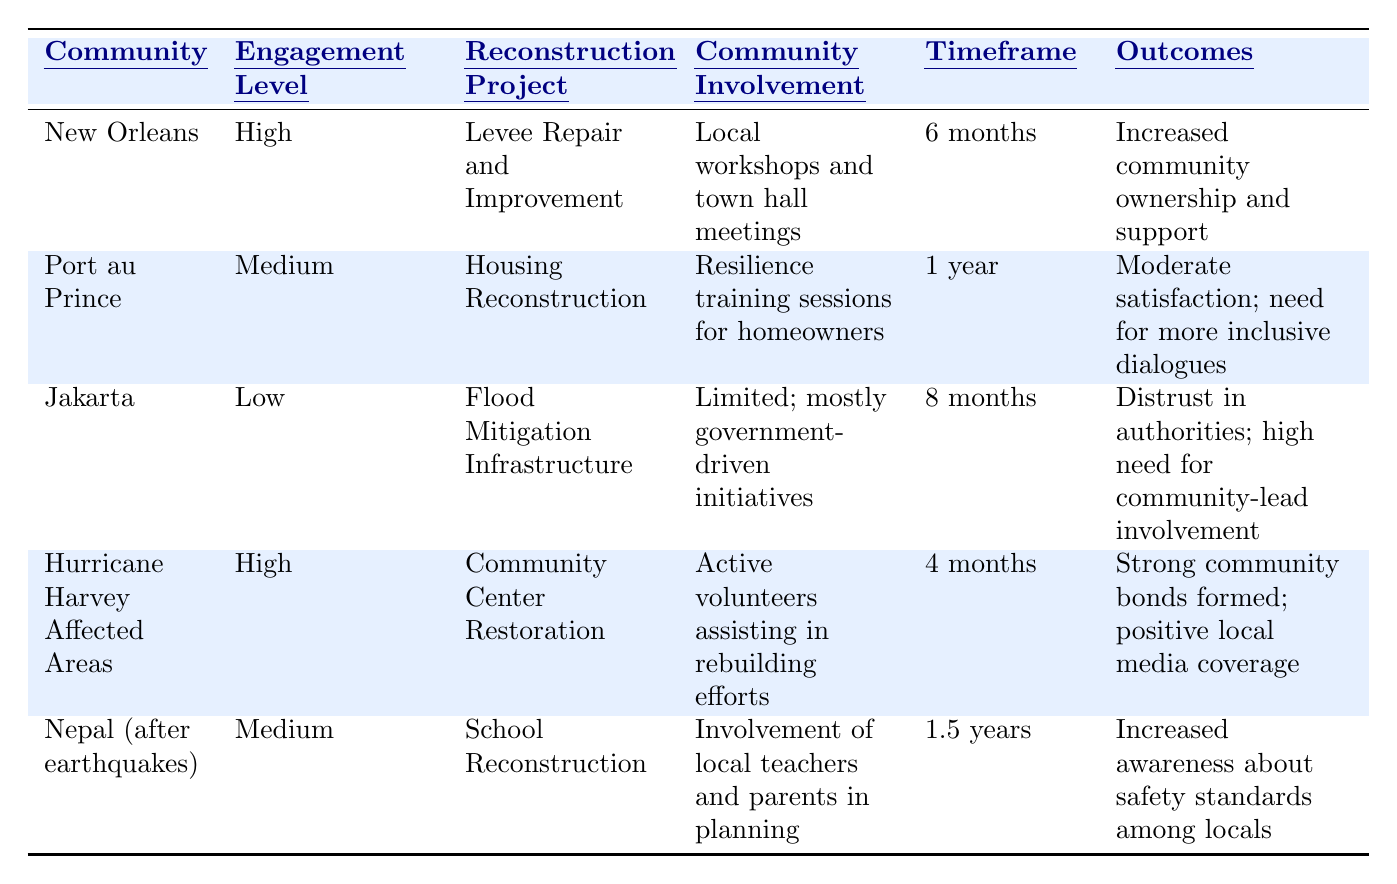What is the engagement level in New Orleans? The table indicates that the engagement level in New Orleans is "High".
Answer: High How long is the timeframe for the housing reconstruction project in Port au Prince? According to the table, the timeframe for the housing reconstruction project in Port au Prince is "1 year".
Answer: 1 year Which community had the lowest engagement level? From the table, Jakarta is listed with the lowest engagement level of "Low".
Answer: Jakarta What type of community involvement was noted in Hurricane Harvey affected areas? The table states that the community involvement in Hurricane Harvey affected areas included "Active volunteers assisting in rebuilding efforts".
Answer: Active volunteers assisting in rebuilding efforts True or false: Community owner involvement in New Orleans increased due to the reconstruction project. The outcomes for New Orleans state "Increased community ownership and support", indicating that this is true.
Answer: True What is the combined timeframe for the reconstruction projects in Port au Prince and Nepal? The timeframe for Port au Prince is 1 year and for Nepal is 1.5 years. Combining these gives 1 year + 1.5 years = 2.5 years.
Answer: 2.5 years How many communities report a medium engagement level? The table shows two communities with a medium engagement level: Port au Prince and Nepal, so there are 2 communities.
Answer: 2 Which community project had the shortest timeframe, and what was the timeframe? The project in Hurricane Harvey affected areas had the shortest timeframe of "4 months".
Answer: Hurricane Center Restoration; 4 months What feedback mechanisms were used in the Jakarta project? The table indicates that the feedback mechanisms used in Jakarta were "Social media polls".
Answer: Social media polls What was the outcome of community involvement in Nepal’s school reconstruction? The outcome listed for Nepal's project is "Increased awareness about safety standards among locals".
Answer: Increased awareness about safety standards among locals 